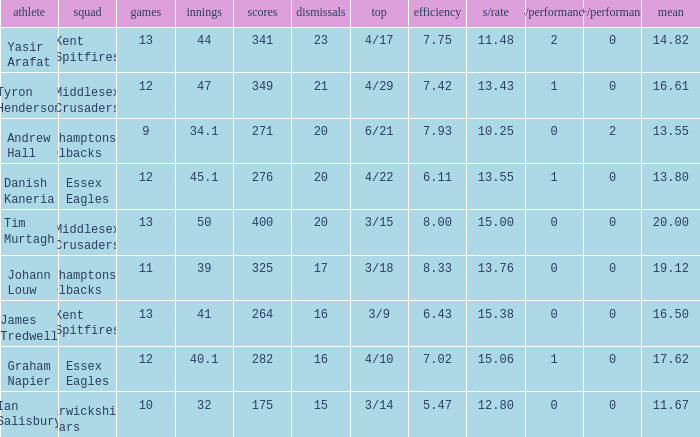Name the most wickets for best is 4/22 20.0. Can you parse all the data within this table? {'header': ['athlete', 'squad', 'games', 'innings', 'scores', 'dismissals', 'top', 'efficiency', 's/rate', '4/performance', '5+/performance', 'mean'], 'rows': [['Yasir Arafat', 'Kent Spitfires', '13', '44', '341', '23', '4/17', '7.75', '11.48', '2', '0', '14.82'], ['Tyron Henderson', 'Middlesex Crusaders', '12', '47', '349', '21', '4/29', '7.42', '13.43', '1', '0', '16.61'], ['Andrew Hall', 'Northamptonshire Steelbacks', '9', '34.1', '271', '20', '6/21', '7.93', '10.25', '0', '2', '13.55'], ['Danish Kaneria', 'Essex Eagles', '12', '45.1', '276', '20', '4/22', '6.11', '13.55', '1', '0', '13.80'], ['Tim Murtagh', 'Middlesex Crusaders', '13', '50', '400', '20', '3/15', '8.00', '15.00', '0', '0', '20.00'], ['Johann Louw', 'Northamptonshire Steelbacks', '11', '39', '325', '17', '3/18', '8.33', '13.76', '0', '0', '19.12'], ['James Tredwell', 'Kent Spitfires', '13', '41', '264', '16', '3/9', '6.43', '15.38', '0', '0', '16.50'], ['Graham Napier', 'Essex Eagles', '12', '40.1', '282', '16', '4/10', '7.02', '15.06', '1', '0', '17.62'], ['Ian Salisbury', 'Warwickshire Bears', '10', '32', '175', '15', '3/14', '5.47', '12.80', '0', '0', '11.67']]} 